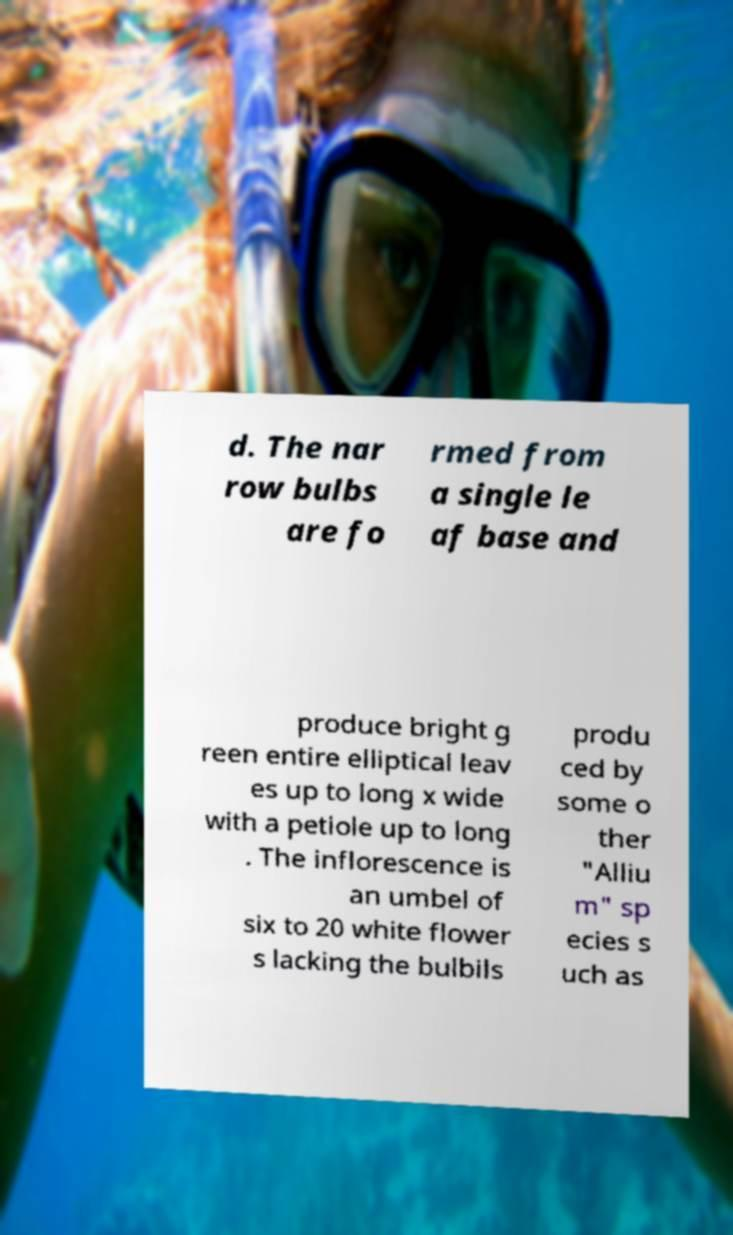Could you assist in decoding the text presented in this image and type it out clearly? d. The nar row bulbs are fo rmed from a single le af base and produce bright g reen entire elliptical leav es up to long x wide with a petiole up to long . The inflorescence is an umbel of six to 20 white flower s lacking the bulbils produ ced by some o ther "Alliu m" sp ecies s uch as 